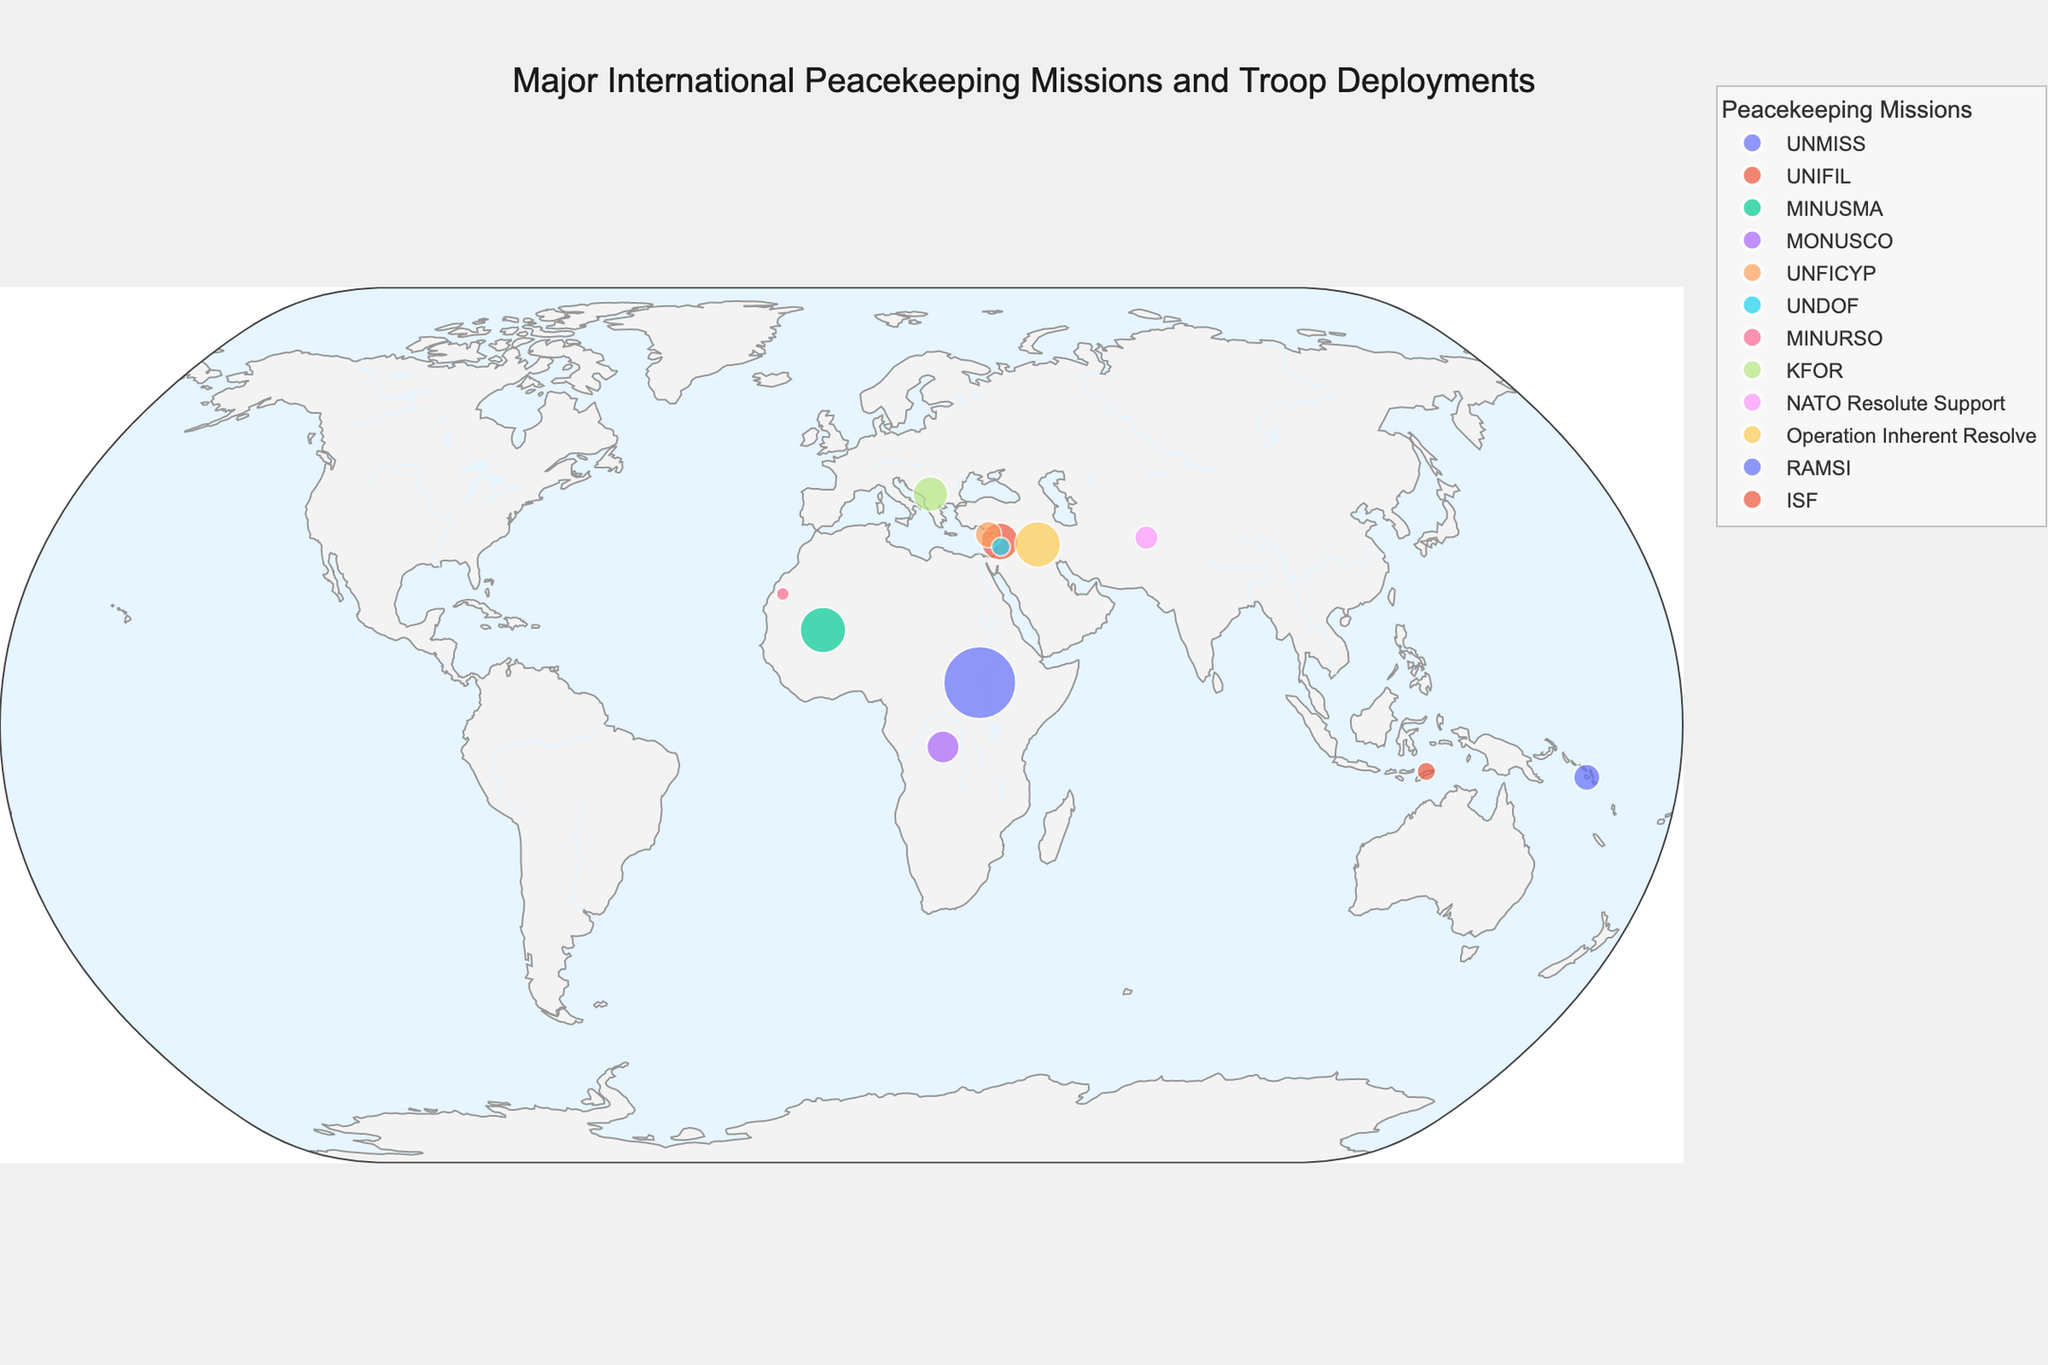What is the title of the figure? The title is prominently displayed at the top of the figure and gives an overview of what the plot represents.
Answer: Major International Peacekeeping Missions and Troop Deployments Which peacekeeping mission has the highest number of troops, and where is it located? The size of the markers and the accompanying hover information indicate the number of troops. The largest marker corresponds to South Sudan with the UNMISS mission.
Answer: UNMISS in South Sudan What is the average number of troops deployed across all missions? Sum the number of troops in all missions and divide by the total number of missions: (750 + 200 + 300 + 150 + 100 + 50 + 25 + 175 + 80 + 300 + 100 + 50) / 12.
Answer: 183.33 How many missions have a deployment of fewer than 100 troops? By reviewing the markers and their sizes on the plot, count those under 100: Golan Heights (50), Western Sahara (25), Afghanistan (80), Timor-Leste (50).
Answer: 4 Which missions are located in Africa, and how many troops are deployed there in total? Check the markers in Africa and sum the troops: South Sudan (750), Mali (300), Democratic Republic of Congo (150), Western Sahara (25). Total = 750 + 300 + 150 + 25.
Answer: 1225 Compare the troop deployments in Lebanon and Kosovo. Which one has more troops? Look at the markers for Lebanon (200 troops) and Kosovo (175 troops).
Answer: Lebanon Which continent has the highest number of peacekeeping missions represented in the figure? Identify the continent locations of the missions: Africa (South Sudan, Mali, DRC, Western Sahara), Asia (Cyprus, Golan Heights, Afghanistan, Iraq, Timor-Leste), Europe (Kosovo), Oceania (Solomon Islands). Africa has the most missions.
Answer: Africa Where is the NATO Resolute Support mission located and how many troops are deployed there? Refer to the hover information on the plot. NATO Resolute Support is in Afghanistan with 80 troops.
Answer: Afghanistan with 80 troops Which mission in the Middle East has the smallest troop deployment? Review the Middle East locations: Lebanon (200 troops), Golan Heights (50 troops), Iraq (300 troops). The smallest is in Golan Heights.
Answer: Golan Heights 